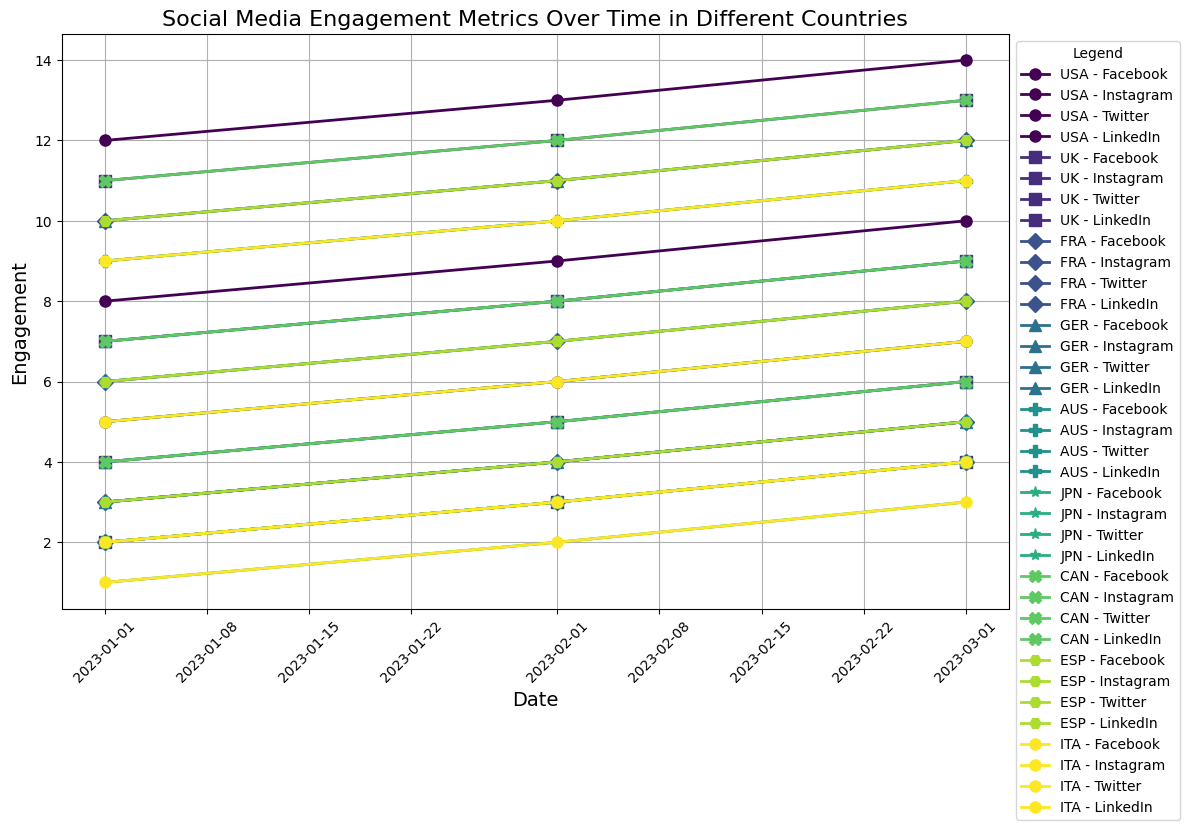What country shows the highest Instagram engagement in March 2023? By reviewing the chart, find the line corresponding to 'Instagram Engagement' for each country and check the values for March 2023. Identify the highest engagement value.
Answer: USA Which country has the lowest LinkedIn engagement in January 2023? Observe the lines representing 'LinkedIn Engagement' on the plot for January 2023. Look for the lowest engagement value.
Answer: JPN How does the Facebook engagement in the USA compare to that of the UK across the three months? Trace the 'Facebook Engagement' lines for both countries across January, February, and March 2023. Compare the values month by month to see which one is higher.
Answer: USA has higher What is the average Twitter engagement for Germany over the three months? Calculate the average of Germany's 'Twitter Engagement' values for January, February, and March 2023. Sum the values (4+5+6) and divide by the number of months (3).
Answer: 5 If you sum the Instagram engagements of France and Italy for February 2023, what do you get? Add the 'Instagram Engagement' values for France and Italy in February 2023: 11 (France) + 10 (Italy).
Answer: 21 Which country has the fastest-growing LinkedIn engagement from January to March 2023? Determine the difference in 'LinkedIn Engagement' values for each country between January and March 2023. Identify the country with the largest increase.
Answer: GER What is the pattern of Twitter engagement for Australia from January to March 2023? Follow the 'Twitter Engagement' line for Australia. Note the values in January, February, and March, looking for increases, decreases, or consistency.
Answer: Increasing Compare the Instagram engagement in March 2023 between Japan and Canada. What do you observe? Locate the 'Instagram Engagement' values for Japan and Canada in March 2023. Compare the two values to see which one is higher.
Answer: CAN higher 